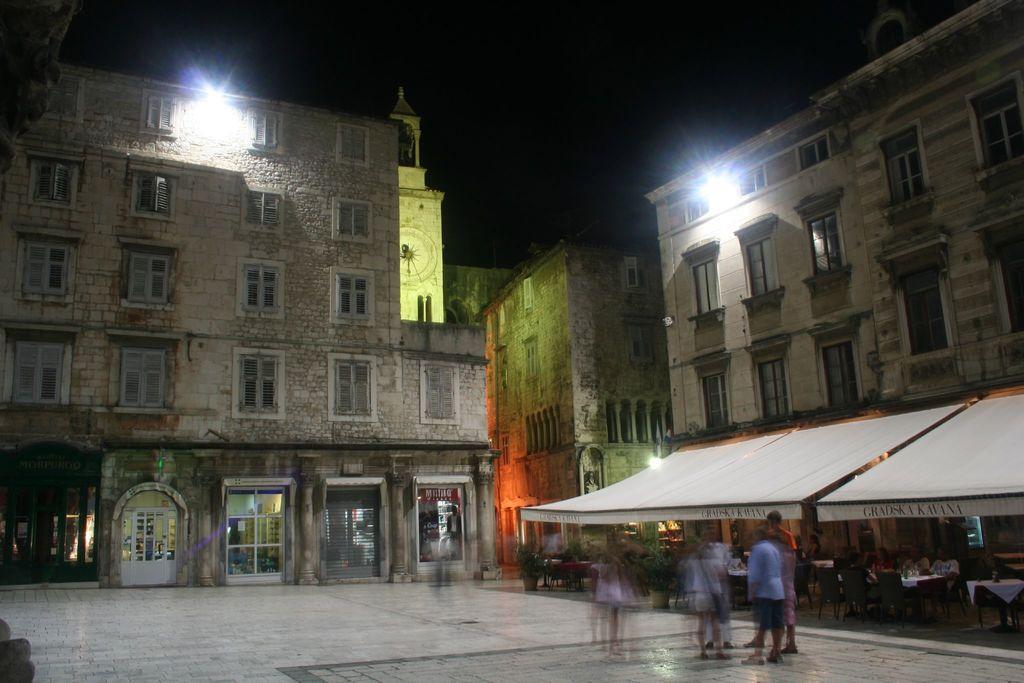Describe this image in one or two sentences. In this image, we can see some buildings. There are lights on the building. There are persons at the bottom of the image standing and wearing clothes. There is a sky at top of the image. 